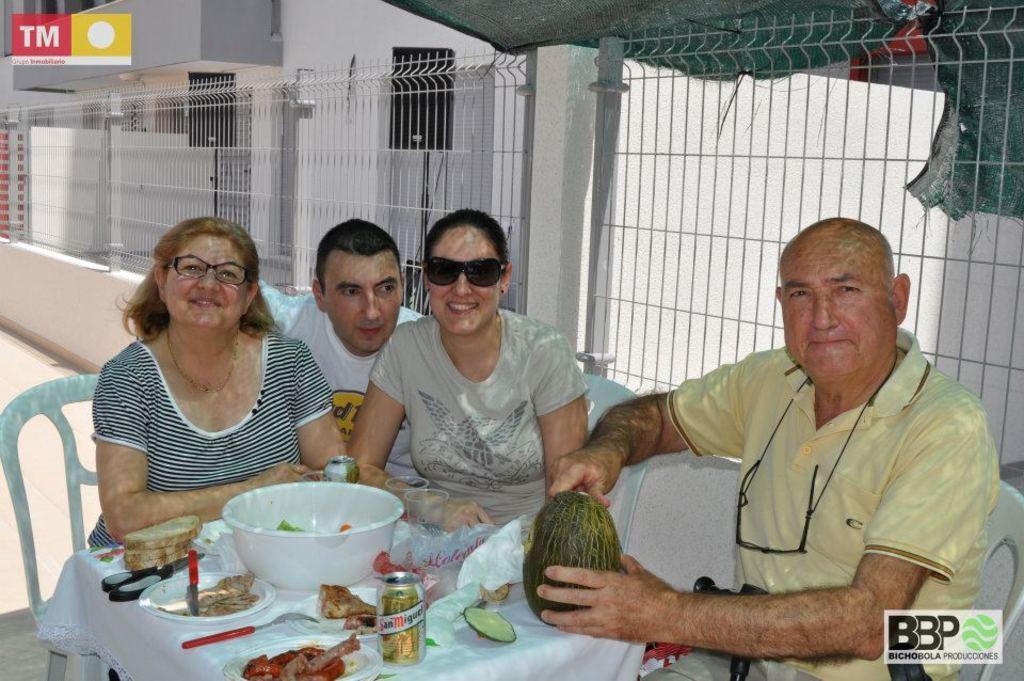In one or two sentences, can you explain what this image depicts? In this image we can see people sitting, before them there is a table and we can see a bowl, glasses, tins, plates, scissor, breads, knife, fork, napkins, food and a fruit placed on the table. In the background there is a fence, tent and a building. 